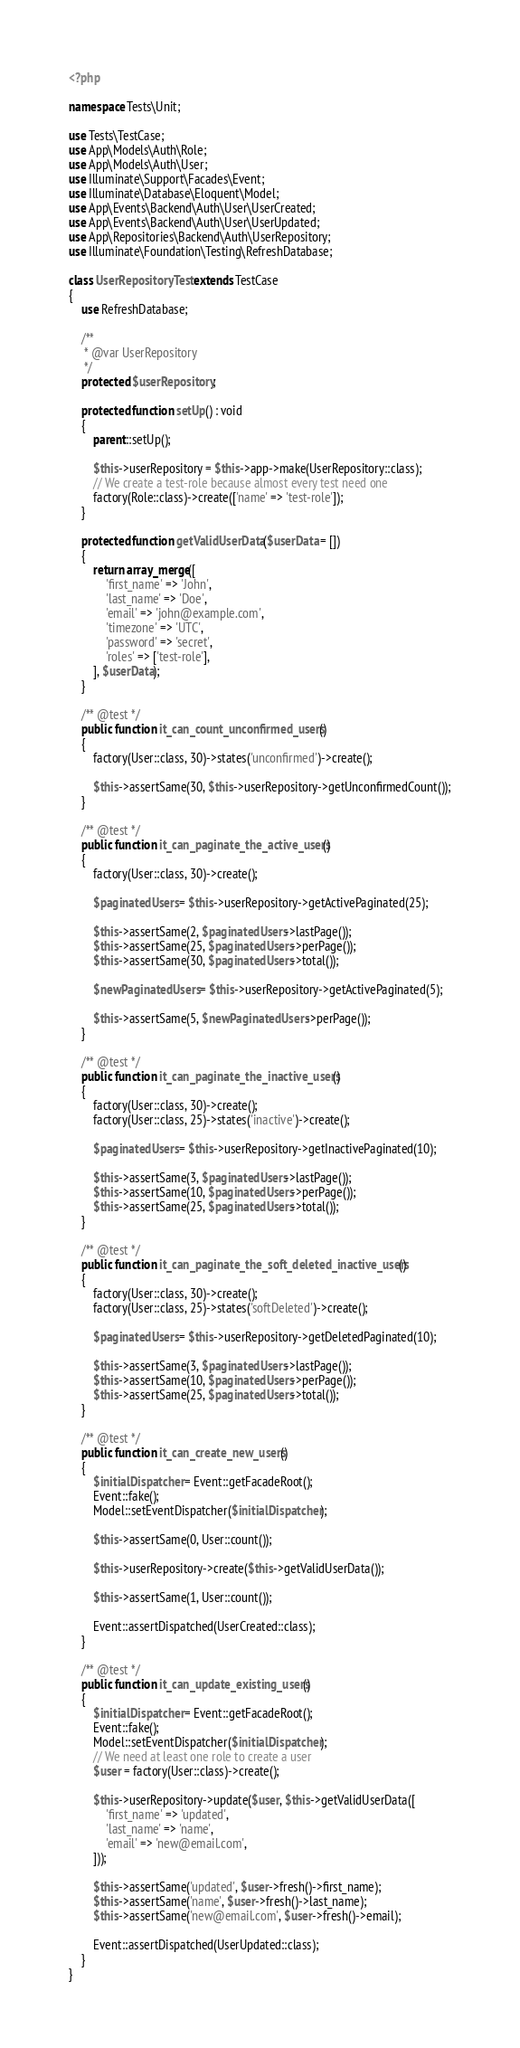Convert code to text. <code><loc_0><loc_0><loc_500><loc_500><_PHP_><?php

namespace Tests\Unit;

use Tests\TestCase;
use App\Models\Auth\Role;
use App\Models\Auth\User;
use Illuminate\Support\Facades\Event;
use Illuminate\Database\Eloquent\Model;
use App\Events\Backend\Auth\User\UserCreated;
use App\Events\Backend\Auth\User\UserUpdated;
use App\Repositories\Backend\Auth\UserRepository;
use Illuminate\Foundation\Testing\RefreshDatabase;

class UserRepositoryTest extends TestCase
{
    use RefreshDatabase;

    /**
     * @var UserRepository
     */
    protected $userRepository;

    protected function setUp() : void
    {
        parent::setUp();

        $this->userRepository = $this->app->make(UserRepository::class);
        // We create a test-role because almost every test need one
        factory(Role::class)->create(['name' => 'test-role']);
    }

    protected function getValidUserData($userData = [])
    {
        return array_merge([
            'first_name' => 'John',
            'last_name' => 'Doe',
            'email' => 'john@example.com',
            'timezone' => 'UTC',
            'password' => 'secret',
            'roles' => ['test-role'],
        ], $userData);
    }

    /** @test */
    public function it_can_count_unconfirmed_users()
    {
        factory(User::class, 30)->states('unconfirmed')->create();

        $this->assertSame(30, $this->userRepository->getUnconfirmedCount());
    }

    /** @test */
    public function it_can_paginate_the_active_users()
    {
        factory(User::class, 30)->create();

        $paginatedUsers = $this->userRepository->getActivePaginated(25);

        $this->assertSame(2, $paginatedUsers->lastPage());
        $this->assertSame(25, $paginatedUsers->perPage());
        $this->assertSame(30, $paginatedUsers->total());

        $newPaginatedUsers = $this->userRepository->getActivePaginated(5);

        $this->assertSame(5, $newPaginatedUsers->perPage());
    }

    /** @test */
    public function it_can_paginate_the_inactive_users()
    {
        factory(User::class, 30)->create();
        factory(User::class, 25)->states('inactive')->create();

        $paginatedUsers = $this->userRepository->getInactivePaginated(10);

        $this->assertSame(3, $paginatedUsers->lastPage());
        $this->assertSame(10, $paginatedUsers->perPage());
        $this->assertSame(25, $paginatedUsers->total());
    }

    /** @test */
    public function it_can_paginate_the_soft_deleted_inactive_users()
    {
        factory(User::class, 30)->create();
        factory(User::class, 25)->states('softDeleted')->create();

        $paginatedUsers = $this->userRepository->getDeletedPaginated(10);

        $this->assertSame(3, $paginatedUsers->lastPage());
        $this->assertSame(10, $paginatedUsers->perPage());
        $this->assertSame(25, $paginatedUsers->total());
    }

    /** @test */
    public function it_can_create_new_users()
    {
        $initialDispatcher = Event::getFacadeRoot();
        Event::fake();
        Model::setEventDispatcher($initialDispatcher);

        $this->assertSame(0, User::count());

        $this->userRepository->create($this->getValidUserData());

        $this->assertSame(1, User::count());

        Event::assertDispatched(UserCreated::class);
    }

    /** @test */
    public function it_can_update_existing_users()
    {
        $initialDispatcher = Event::getFacadeRoot();
        Event::fake();
        Model::setEventDispatcher($initialDispatcher);
        // We need at least one role to create a user
        $user = factory(User::class)->create();

        $this->userRepository->update($user, $this->getValidUserData([
            'first_name' => 'updated',
            'last_name' => 'name',
            'email' => 'new@email.com',
        ]));

        $this->assertSame('updated', $user->fresh()->first_name);
        $this->assertSame('name', $user->fresh()->last_name);
        $this->assertSame('new@email.com', $user->fresh()->email);

        Event::assertDispatched(UserUpdated::class);
    }
}
</code> 